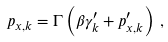<formula> <loc_0><loc_0><loc_500><loc_500>p _ { x , k } = \Gamma \left ( \beta \gamma ^ { \prime } _ { k } + p ^ { \prime } _ { x , k } \right ) \, ,</formula> 